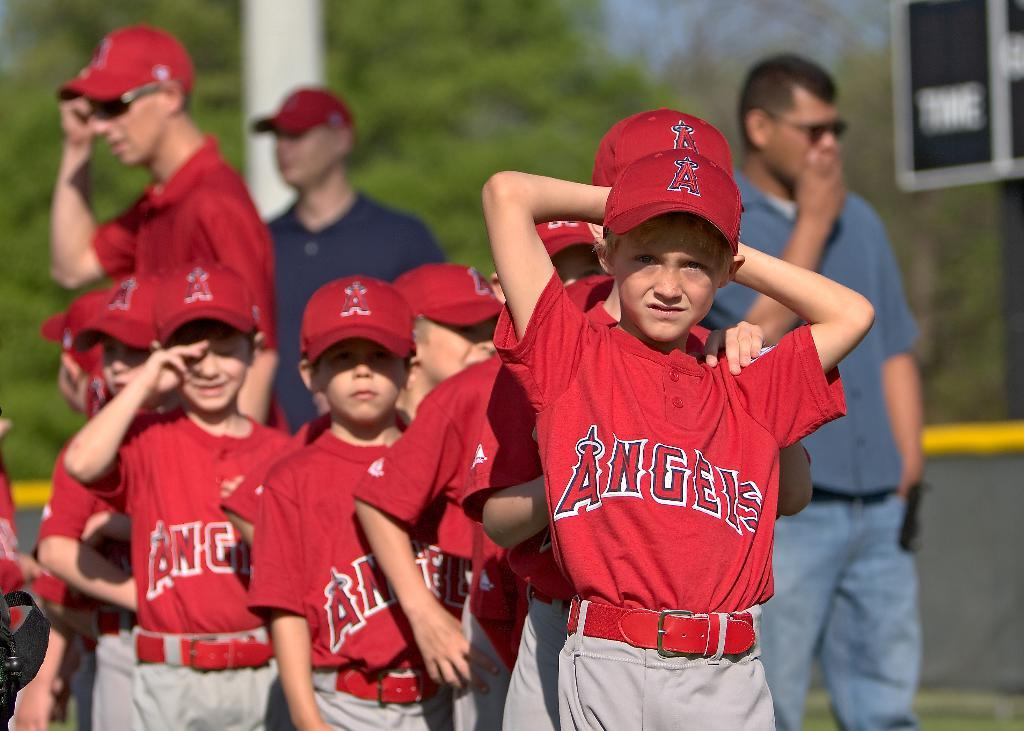Provide a one-sentence caption for the provided image. Baseball players from the Angels posing for the camera. 